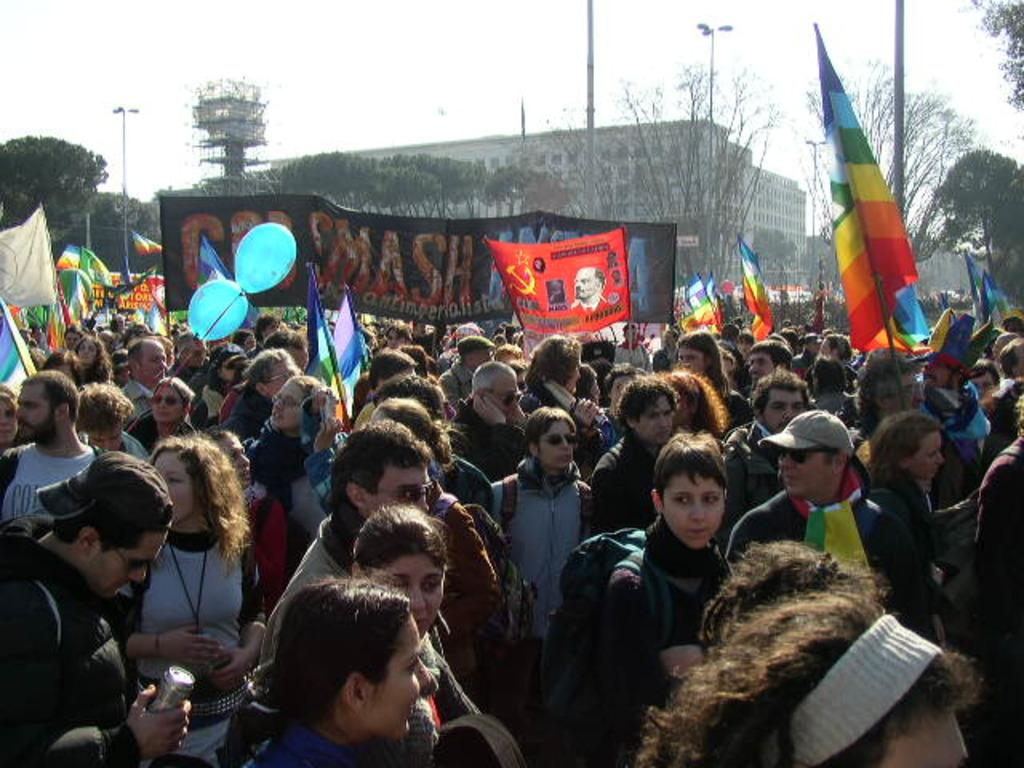What are the people in the image holding? The people in the image are holding banners. What else can be seen in the image besides people holding banners? There are flags, balloons, buildings, trees, poles, and the sky visible in the image. Can you describe the objects that are attached to the poles? The objects attached to the poles are flags. What type of natural elements can be seen in the image? Trees are the natural elements visible in the image. How many news articles are present in the image? There are no news articles present in the image. What type of weather can be seen in the image, given the presence of thunder? There is no mention of thunder in the image, and therefore it cannot be determined from the image. 